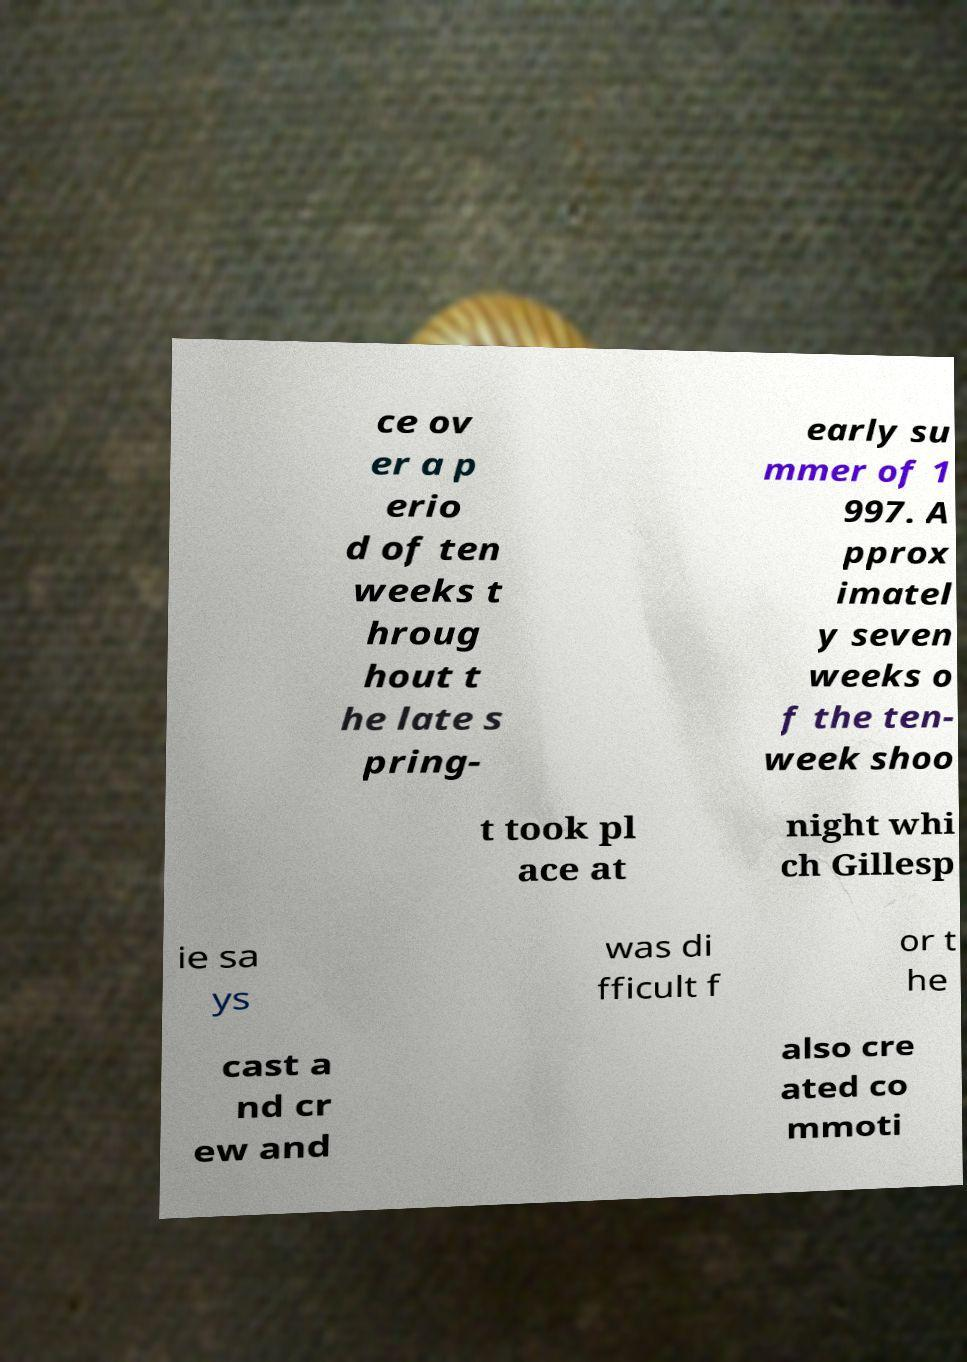Please identify and transcribe the text found in this image. ce ov er a p erio d of ten weeks t hroug hout t he late s pring- early su mmer of 1 997. A pprox imatel y seven weeks o f the ten- week shoo t took pl ace at night whi ch Gillesp ie sa ys was di fficult f or t he cast a nd cr ew and also cre ated co mmoti 